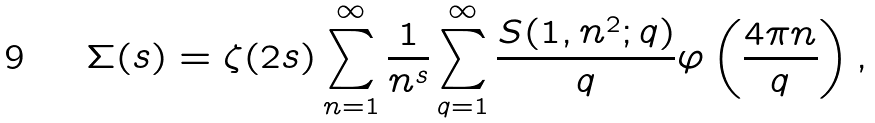<formula> <loc_0><loc_0><loc_500><loc_500>\Sigma ( s ) = \zeta ( 2 s ) \sum _ { n = 1 } ^ { \infty } \frac { 1 } { n ^ { s } } \sum _ { q = 1 } ^ { \infty } \frac { S ( 1 , n ^ { 2 } ; q ) } { q } \varphi \left ( \frac { 4 \pi n } { q } \right ) ,</formula> 